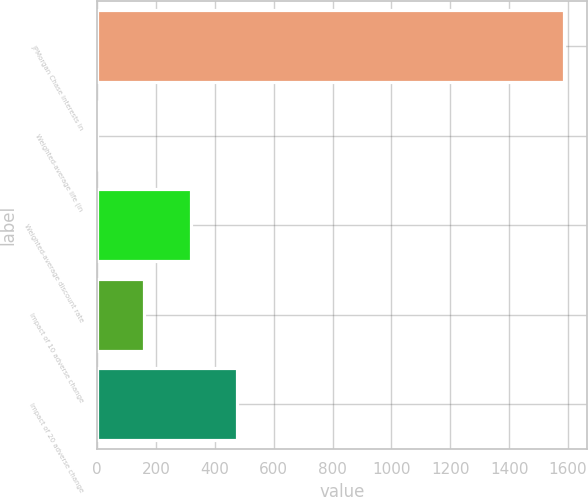Convert chart to OTSL. <chart><loc_0><loc_0><loc_500><loc_500><bar_chart><fcel>JPMorgan Chase interests in<fcel>Weighted-average life (in<fcel>Weighted-average discount rate<fcel>Impact of 10 adverse change<fcel>Impact of 20 adverse change<nl><fcel>1585<fcel>1<fcel>317.8<fcel>159.4<fcel>476.2<nl></chart> 